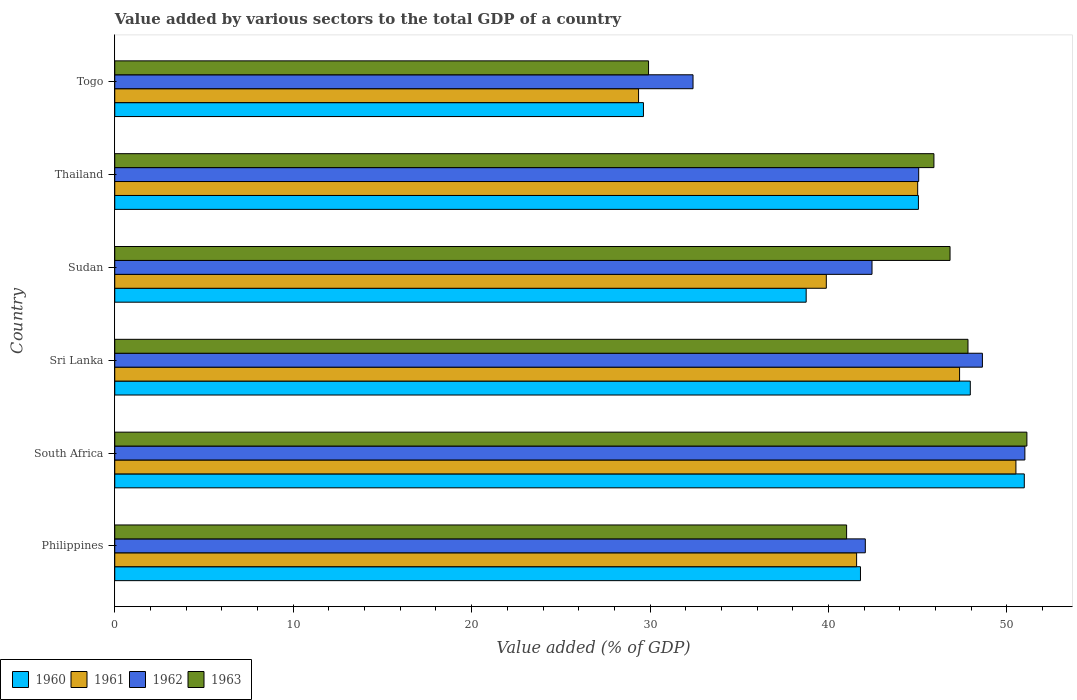How many different coloured bars are there?
Offer a very short reply. 4. Are the number of bars per tick equal to the number of legend labels?
Provide a short and direct response. Yes. How many bars are there on the 4th tick from the top?
Make the answer very short. 4. What is the label of the 5th group of bars from the top?
Make the answer very short. South Africa. In how many cases, is the number of bars for a given country not equal to the number of legend labels?
Offer a terse response. 0. What is the value added by various sectors to the total GDP in 1963 in Sudan?
Ensure brevity in your answer.  46.81. Across all countries, what is the maximum value added by various sectors to the total GDP in 1963?
Provide a short and direct response. 51.12. Across all countries, what is the minimum value added by various sectors to the total GDP in 1962?
Offer a very short reply. 32.41. In which country was the value added by various sectors to the total GDP in 1961 maximum?
Offer a very short reply. South Africa. In which country was the value added by various sectors to the total GDP in 1960 minimum?
Provide a short and direct response. Togo. What is the total value added by various sectors to the total GDP in 1963 in the graph?
Keep it short and to the point. 262.58. What is the difference between the value added by various sectors to the total GDP in 1960 in Philippines and that in Sri Lanka?
Keep it short and to the point. -6.15. What is the difference between the value added by various sectors to the total GDP in 1960 in Thailand and the value added by various sectors to the total GDP in 1962 in Sri Lanka?
Offer a terse response. -3.59. What is the average value added by various sectors to the total GDP in 1962 per country?
Make the answer very short. 43.6. What is the difference between the value added by various sectors to the total GDP in 1962 and value added by various sectors to the total GDP in 1961 in South Africa?
Make the answer very short. 0.5. What is the ratio of the value added by various sectors to the total GDP in 1962 in Philippines to that in Sri Lanka?
Offer a terse response. 0.87. Is the value added by various sectors to the total GDP in 1960 in Thailand less than that in Togo?
Give a very brief answer. No. Is the difference between the value added by various sectors to the total GDP in 1962 in South Africa and Sudan greater than the difference between the value added by various sectors to the total GDP in 1961 in South Africa and Sudan?
Make the answer very short. No. What is the difference between the highest and the second highest value added by various sectors to the total GDP in 1963?
Your answer should be compact. 3.3. What is the difference between the highest and the lowest value added by various sectors to the total GDP in 1963?
Provide a short and direct response. 21.2. In how many countries, is the value added by various sectors to the total GDP in 1963 greater than the average value added by various sectors to the total GDP in 1963 taken over all countries?
Your answer should be very brief. 4. Is the sum of the value added by various sectors to the total GDP in 1962 in Sudan and Togo greater than the maximum value added by various sectors to the total GDP in 1960 across all countries?
Your response must be concise. Yes. Is it the case that in every country, the sum of the value added by various sectors to the total GDP in 1962 and value added by various sectors to the total GDP in 1963 is greater than the sum of value added by various sectors to the total GDP in 1960 and value added by various sectors to the total GDP in 1961?
Give a very brief answer. No. Is it the case that in every country, the sum of the value added by various sectors to the total GDP in 1963 and value added by various sectors to the total GDP in 1960 is greater than the value added by various sectors to the total GDP in 1962?
Offer a very short reply. Yes. How many bars are there?
Provide a short and direct response. 24. What is the difference between two consecutive major ticks on the X-axis?
Your answer should be very brief. 10. Does the graph contain grids?
Provide a short and direct response. No. How many legend labels are there?
Provide a short and direct response. 4. What is the title of the graph?
Ensure brevity in your answer.  Value added by various sectors to the total GDP of a country. Does "1982" appear as one of the legend labels in the graph?
Your answer should be very brief. No. What is the label or title of the X-axis?
Offer a terse response. Value added (% of GDP). What is the label or title of the Y-axis?
Keep it short and to the point. Country. What is the Value added (% of GDP) in 1960 in Philippines?
Keep it short and to the point. 41.79. What is the Value added (% of GDP) in 1961 in Philippines?
Offer a terse response. 41.57. What is the Value added (% of GDP) of 1962 in Philippines?
Ensure brevity in your answer.  42.06. What is the Value added (% of GDP) in 1963 in Philippines?
Keep it short and to the point. 41.01. What is the Value added (% of GDP) of 1960 in South Africa?
Offer a terse response. 50.97. What is the Value added (% of GDP) in 1961 in South Africa?
Your response must be concise. 50.5. What is the Value added (% of GDP) in 1962 in South Africa?
Keep it short and to the point. 51.01. What is the Value added (% of GDP) of 1963 in South Africa?
Offer a very short reply. 51.12. What is the Value added (% of GDP) of 1960 in Sri Lanka?
Keep it short and to the point. 47.95. What is the Value added (% of GDP) in 1961 in Sri Lanka?
Give a very brief answer. 47.35. What is the Value added (% of GDP) of 1962 in Sri Lanka?
Keep it short and to the point. 48.62. What is the Value added (% of GDP) of 1963 in Sri Lanka?
Provide a succinct answer. 47.82. What is the Value added (% of GDP) of 1960 in Sudan?
Offer a very short reply. 38.75. What is the Value added (% of GDP) in 1961 in Sudan?
Ensure brevity in your answer.  39.88. What is the Value added (% of GDP) of 1962 in Sudan?
Ensure brevity in your answer.  42.44. What is the Value added (% of GDP) in 1963 in Sudan?
Offer a very short reply. 46.81. What is the Value added (% of GDP) in 1960 in Thailand?
Keep it short and to the point. 45.04. What is the Value added (% of GDP) in 1961 in Thailand?
Your response must be concise. 45. What is the Value added (% of GDP) of 1962 in Thailand?
Offer a very short reply. 45.05. What is the Value added (% of GDP) in 1963 in Thailand?
Make the answer very short. 45.91. What is the Value added (% of GDP) of 1960 in Togo?
Ensure brevity in your answer.  29.63. What is the Value added (% of GDP) in 1961 in Togo?
Your answer should be compact. 29.35. What is the Value added (% of GDP) in 1962 in Togo?
Provide a succinct answer. 32.41. What is the Value added (% of GDP) of 1963 in Togo?
Your answer should be compact. 29.91. Across all countries, what is the maximum Value added (% of GDP) of 1960?
Give a very brief answer. 50.97. Across all countries, what is the maximum Value added (% of GDP) of 1961?
Offer a terse response. 50.5. Across all countries, what is the maximum Value added (% of GDP) in 1962?
Provide a short and direct response. 51.01. Across all countries, what is the maximum Value added (% of GDP) in 1963?
Give a very brief answer. 51.12. Across all countries, what is the minimum Value added (% of GDP) of 1960?
Your answer should be compact. 29.63. Across all countries, what is the minimum Value added (% of GDP) in 1961?
Your response must be concise. 29.35. Across all countries, what is the minimum Value added (% of GDP) in 1962?
Offer a terse response. 32.41. Across all countries, what is the minimum Value added (% of GDP) in 1963?
Offer a very short reply. 29.91. What is the total Value added (% of GDP) in 1960 in the graph?
Keep it short and to the point. 254.13. What is the total Value added (% of GDP) of 1961 in the graph?
Ensure brevity in your answer.  253.65. What is the total Value added (% of GDP) of 1962 in the graph?
Give a very brief answer. 261.59. What is the total Value added (% of GDP) of 1963 in the graph?
Your response must be concise. 262.58. What is the difference between the Value added (% of GDP) in 1960 in Philippines and that in South Africa?
Your answer should be very brief. -9.18. What is the difference between the Value added (% of GDP) in 1961 in Philippines and that in South Africa?
Your response must be concise. -8.93. What is the difference between the Value added (% of GDP) in 1962 in Philippines and that in South Africa?
Give a very brief answer. -8.94. What is the difference between the Value added (% of GDP) of 1963 in Philippines and that in South Africa?
Give a very brief answer. -10.1. What is the difference between the Value added (% of GDP) in 1960 in Philippines and that in Sri Lanka?
Provide a short and direct response. -6.15. What is the difference between the Value added (% of GDP) in 1961 in Philippines and that in Sri Lanka?
Provide a succinct answer. -5.77. What is the difference between the Value added (% of GDP) of 1962 in Philippines and that in Sri Lanka?
Give a very brief answer. -6.56. What is the difference between the Value added (% of GDP) of 1963 in Philippines and that in Sri Lanka?
Offer a terse response. -6.8. What is the difference between the Value added (% of GDP) in 1960 in Philippines and that in Sudan?
Keep it short and to the point. 3.04. What is the difference between the Value added (% of GDP) of 1961 in Philippines and that in Sudan?
Your answer should be compact. 1.7. What is the difference between the Value added (% of GDP) of 1962 in Philippines and that in Sudan?
Give a very brief answer. -0.38. What is the difference between the Value added (% of GDP) in 1963 in Philippines and that in Sudan?
Your response must be concise. -5.8. What is the difference between the Value added (% of GDP) of 1960 in Philippines and that in Thailand?
Give a very brief answer. -3.25. What is the difference between the Value added (% of GDP) in 1961 in Philippines and that in Thailand?
Keep it short and to the point. -3.42. What is the difference between the Value added (% of GDP) of 1962 in Philippines and that in Thailand?
Ensure brevity in your answer.  -2.99. What is the difference between the Value added (% of GDP) in 1963 in Philippines and that in Thailand?
Your response must be concise. -4.89. What is the difference between the Value added (% of GDP) in 1960 in Philippines and that in Togo?
Offer a terse response. 12.16. What is the difference between the Value added (% of GDP) in 1961 in Philippines and that in Togo?
Give a very brief answer. 12.22. What is the difference between the Value added (% of GDP) of 1962 in Philippines and that in Togo?
Provide a short and direct response. 9.66. What is the difference between the Value added (% of GDP) of 1963 in Philippines and that in Togo?
Make the answer very short. 11.1. What is the difference between the Value added (% of GDP) of 1960 in South Africa and that in Sri Lanka?
Provide a succinct answer. 3.03. What is the difference between the Value added (% of GDP) in 1961 in South Africa and that in Sri Lanka?
Your answer should be very brief. 3.16. What is the difference between the Value added (% of GDP) of 1962 in South Africa and that in Sri Lanka?
Offer a terse response. 2.38. What is the difference between the Value added (% of GDP) in 1963 in South Africa and that in Sri Lanka?
Offer a terse response. 3.3. What is the difference between the Value added (% of GDP) of 1960 in South Africa and that in Sudan?
Make the answer very short. 12.22. What is the difference between the Value added (% of GDP) in 1961 in South Africa and that in Sudan?
Provide a short and direct response. 10.63. What is the difference between the Value added (% of GDP) of 1962 in South Africa and that in Sudan?
Your response must be concise. 8.57. What is the difference between the Value added (% of GDP) in 1963 in South Africa and that in Sudan?
Offer a very short reply. 4.31. What is the difference between the Value added (% of GDP) in 1960 in South Africa and that in Thailand?
Provide a succinct answer. 5.93. What is the difference between the Value added (% of GDP) in 1961 in South Africa and that in Thailand?
Provide a succinct answer. 5.51. What is the difference between the Value added (% of GDP) of 1962 in South Africa and that in Thailand?
Keep it short and to the point. 5.95. What is the difference between the Value added (% of GDP) in 1963 in South Africa and that in Thailand?
Offer a terse response. 5.21. What is the difference between the Value added (% of GDP) of 1960 in South Africa and that in Togo?
Make the answer very short. 21.34. What is the difference between the Value added (% of GDP) of 1961 in South Africa and that in Togo?
Give a very brief answer. 21.15. What is the difference between the Value added (% of GDP) of 1962 in South Africa and that in Togo?
Your answer should be very brief. 18.6. What is the difference between the Value added (% of GDP) of 1963 in South Africa and that in Togo?
Offer a very short reply. 21.2. What is the difference between the Value added (% of GDP) of 1960 in Sri Lanka and that in Sudan?
Make the answer very short. 9.2. What is the difference between the Value added (% of GDP) in 1961 in Sri Lanka and that in Sudan?
Provide a succinct answer. 7.47. What is the difference between the Value added (% of GDP) in 1962 in Sri Lanka and that in Sudan?
Ensure brevity in your answer.  6.19. What is the difference between the Value added (% of GDP) in 1960 in Sri Lanka and that in Thailand?
Give a very brief answer. 2.91. What is the difference between the Value added (% of GDP) in 1961 in Sri Lanka and that in Thailand?
Give a very brief answer. 2.35. What is the difference between the Value added (% of GDP) of 1962 in Sri Lanka and that in Thailand?
Your answer should be compact. 3.57. What is the difference between the Value added (% of GDP) of 1963 in Sri Lanka and that in Thailand?
Your answer should be very brief. 1.91. What is the difference between the Value added (% of GDP) of 1960 in Sri Lanka and that in Togo?
Keep it short and to the point. 18.32. What is the difference between the Value added (% of GDP) in 1961 in Sri Lanka and that in Togo?
Offer a very short reply. 17.99. What is the difference between the Value added (% of GDP) of 1962 in Sri Lanka and that in Togo?
Your response must be concise. 16.22. What is the difference between the Value added (% of GDP) of 1963 in Sri Lanka and that in Togo?
Make the answer very short. 17.9. What is the difference between the Value added (% of GDP) of 1960 in Sudan and that in Thailand?
Your response must be concise. -6.29. What is the difference between the Value added (% of GDP) in 1961 in Sudan and that in Thailand?
Your answer should be compact. -5.12. What is the difference between the Value added (% of GDP) in 1962 in Sudan and that in Thailand?
Your answer should be very brief. -2.62. What is the difference between the Value added (% of GDP) in 1963 in Sudan and that in Thailand?
Your answer should be compact. 0.9. What is the difference between the Value added (% of GDP) of 1960 in Sudan and that in Togo?
Ensure brevity in your answer.  9.12. What is the difference between the Value added (% of GDP) in 1961 in Sudan and that in Togo?
Your answer should be compact. 10.52. What is the difference between the Value added (% of GDP) in 1962 in Sudan and that in Togo?
Offer a very short reply. 10.03. What is the difference between the Value added (% of GDP) of 1963 in Sudan and that in Togo?
Ensure brevity in your answer.  16.9. What is the difference between the Value added (% of GDP) of 1960 in Thailand and that in Togo?
Provide a succinct answer. 15.41. What is the difference between the Value added (% of GDP) of 1961 in Thailand and that in Togo?
Offer a very short reply. 15.64. What is the difference between the Value added (% of GDP) of 1962 in Thailand and that in Togo?
Keep it short and to the point. 12.65. What is the difference between the Value added (% of GDP) in 1963 in Thailand and that in Togo?
Your answer should be compact. 15.99. What is the difference between the Value added (% of GDP) of 1960 in Philippines and the Value added (% of GDP) of 1961 in South Africa?
Offer a very short reply. -8.71. What is the difference between the Value added (% of GDP) in 1960 in Philippines and the Value added (% of GDP) in 1962 in South Africa?
Your response must be concise. -9.21. What is the difference between the Value added (% of GDP) in 1960 in Philippines and the Value added (% of GDP) in 1963 in South Africa?
Give a very brief answer. -9.33. What is the difference between the Value added (% of GDP) in 1961 in Philippines and the Value added (% of GDP) in 1962 in South Africa?
Provide a succinct answer. -9.43. What is the difference between the Value added (% of GDP) of 1961 in Philippines and the Value added (% of GDP) of 1963 in South Africa?
Make the answer very short. -9.54. What is the difference between the Value added (% of GDP) of 1962 in Philippines and the Value added (% of GDP) of 1963 in South Africa?
Give a very brief answer. -9.05. What is the difference between the Value added (% of GDP) in 1960 in Philippines and the Value added (% of GDP) in 1961 in Sri Lanka?
Your answer should be compact. -5.55. What is the difference between the Value added (% of GDP) of 1960 in Philippines and the Value added (% of GDP) of 1962 in Sri Lanka?
Give a very brief answer. -6.83. What is the difference between the Value added (% of GDP) in 1960 in Philippines and the Value added (% of GDP) in 1963 in Sri Lanka?
Your answer should be very brief. -6.03. What is the difference between the Value added (% of GDP) of 1961 in Philippines and the Value added (% of GDP) of 1962 in Sri Lanka?
Keep it short and to the point. -7.05. What is the difference between the Value added (% of GDP) in 1961 in Philippines and the Value added (% of GDP) in 1963 in Sri Lanka?
Provide a short and direct response. -6.24. What is the difference between the Value added (% of GDP) of 1962 in Philippines and the Value added (% of GDP) of 1963 in Sri Lanka?
Give a very brief answer. -5.75. What is the difference between the Value added (% of GDP) in 1960 in Philippines and the Value added (% of GDP) in 1961 in Sudan?
Offer a very short reply. 1.91. What is the difference between the Value added (% of GDP) of 1960 in Philippines and the Value added (% of GDP) of 1962 in Sudan?
Provide a succinct answer. -0.65. What is the difference between the Value added (% of GDP) of 1960 in Philippines and the Value added (% of GDP) of 1963 in Sudan?
Give a very brief answer. -5.02. What is the difference between the Value added (% of GDP) of 1961 in Philippines and the Value added (% of GDP) of 1962 in Sudan?
Your response must be concise. -0.86. What is the difference between the Value added (% of GDP) of 1961 in Philippines and the Value added (% of GDP) of 1963 in Sudan?
Provide a succinct answer. -5.24. What is the difference between the Value added (% of GDP) of 1962 in Philippines and the Value added (% of GDP) of 1963 in Sudan?
Keep it short and to the point. -4.75. What is the difference between the Value added (% of GDP) of 1960 in Philippines and the Value added (% of GDP) of 1961 in Thailand?
Provide a short and direct response. -3.21. What is the difference between the Value added (% of GDP) of 1960 in Philippines and the Value added (% of GDP) of 1962 in Thailand?
Offer a terse response. -3.26. What is the difference between the Value added (% of GDP) of 1960 in Philippines and the Value added (% of GDP) of 1963 in Thailand?
Keep it short and to the point. -4.12. What is the difference between the Value added (% of GDP) in 1961 in Philippines and the Value added (% of GDP) in 1962 in Thailand?
Your response must be concise. -3.48. What is the difference between the Value added (% of GDP) of 1961 in Philippines and the Value added (% of GDP) of 1963 in Thailand?
Your response must be concise. -4.33. What is the difference between the Value added (% of GDP) of 1962 in Philippines and the Value added (% of GDP) of 1963 in Thailand?
Provide a short and direct response. -3.84. What is the difference between the Value added (% of GDP) in 1960 in Philippines and the Value added (% of GDP) in 1961 in Togo?
Offer a very short reply. 12.44. What is the difference between the Value added (% of GDP) of 1960 in Philippines and the Value added (% of GDP) of 1962 in Togo?
Your answer should be very brief. 9.38. What is the difference between the Value added (% of GDP) in 1960 in Philippines and the Value added (% of GDP) in 1963 in Togo?
Your answer should be compact. 11.88. What is the difference between the Value added (% of GDP) in 1961 in Philippines and the Value added (% of GDP) in 1962 in Togo?
Your answer should be compact. 9.17. What is the difference between the Value added (% of GDP) of 1961 in Philippines and the Value added (% of GDP) of 1963 in Togo?
Your answer should be compact. 11.66. What is the difference between the Value added (% of GDP) of 1962 in Philippines and the Value added (% of GDP) of 1963 in Togo?
Offer a terse response. 12.15. What is the difference between the Value added (% of GDP) of 1960 in South Africa and the Value added (% of GDP) of 1961 in Sri Lanka?
Give a very brief answer. 3.63. What is the difference between the Value added (% of GDP) in 1960 in South Africa and the Value added (% of GDP) in 1962 in Sri Lanka?
Your answer should be compact. 2.35. What is the difference between the Value added (% of GDP) in 1960 in South Africa and the Value added (% of GDP) in 1963 in Sri Lanka?
Offer a very short reply. 3.16. What is the difference between the Value added (% of GDP) of 1961 in South Africa and the Value added (% of GDP) of 1962 in Sri Lanka?
Make the answer very short. 1.88. What is the difference between the Value added (% of GDP) of 1961 in South Africa and the Value added (% of GDP) of 1963 in Sri Lanka?
Offer a very short reply. 2.69. What is the difference between the Value added (% of GDP) of 1962 in South Africa and the Value added (% of GDP) of 1963 in Sri Lanka?
Offer a terse response. 3.19. What is the difference between the Value added (% of GDP) in 1960 in South Africa and the Value added (% of GDP) in 1961 in Sudan?
Your answer should be compact. 11.09. What is the difference between the Value added (% of GDP) in 1960 in South Africa and the Value added (% of GDP) in 1962 in Sudan?
Offer a very short reply. 8.53. What is the difference between the Value added (% of GDP) of 1960 in South Africa and the Value added (% of GDP) of 1963 in Sudan?
Provide a short and direct response. 4.16. What is the difference between the Value added (% of GDP) in 1961 in South Africa and the Value added (% of GDP) in 1962 in Sudan?
Give a very brief answer. 8.07. What is the difference between the Value added (% of GDP) of 1961 in South Africa and the Value added (% of GDP) of 1963 in Sudan?
Your answer should be compact. 3.69. What is the difference between the Value added (% of GDP) in 1962 in South Africa and the Value added (% of GDP) in 1963 in Sudan?
Give a very brief answer. 4.19. What is the difference between the Value added (% of GDP) in 1960 in South Africa and the Value added (% of GDP) in 1961 in Thailand?
Ensure brevity in your answer.  5.98. What is the difference between the Value added (% of GDP) of 1960 in South Africa and the Value added (% of GDP) of 1962 in Thailand?
Your answer should be compact. 5.92. What is the difference between the Value added (% of GDP) of 1960 in South Africa and the Value added (% of GDP) of 1963 in Thailand?
Provide a short and direct response. 5.06. What is the difference between the Value added (% of GDP) in 1961 in South Africa and the Value added (% of GDP) in 1962 in Thailand?
Your answer should be compact. 5.45. What is the difference between the Value added (% of GDP) in 1961 in South Africa and the Value added (% of GDP) in 1963 in Thailand?
Ensure brevity in your answer.  4.6. What is the difference between the Value added (% of GDP) of 1962 in South Africa and the Value added (% of GDP) of 1963 in Thailand?
Your answer should be compact. 5.1. What is the difference between the Value added (% of GDP) in 1960 in South Africa and the Value added (% of GDP) in 1961 in Togo?
Provide a succinct answer. 21.62. What is the difference between the Value added (% of GDP) of 1960 in South Africa and the Value added (% of GDP) of 1962 in Togo?
Offer a terse response. 18.56. What is the difference between the Value added (% of GDP) of 1960 in South Africa and the Value added (% of GDP) of 1963 in Togo?
Offer a very short reply. 21.06. What is the difference between the Value added (% of GDP) of 1961 in South Africa and the Value added (% of GDP) of 1962 in Togo?
Give a very brief answer. 18.1. What is the difference between the Value added (% of GDP) in 1961 in South Africa and the Value added (% of GDP) in 1963 in Togo?
Make the answer very short. 20.59. What is the difference between the Value added (% of GDP) of 1962 in South Africa and the Value added (% of GDP) of 1963 in Togo?
Make the answer very short. 21.09. What is the difference between the Value added (% of GDP) in 1960 in Sri Lanka and the Value added (% of GDP) in 1961 in Sudan?
Offer a very short reply. 8.07. What is the difference between the Value added (% of GDP) in 1960 in Sri Lanka and the Value added (% of GDP) in 1962 in Sudan?
Provide a succinct answer. 5.51. What is the difference between the Value added (% of GDP) of 1960 in Sri Lanka and the Value added (% of GDP) of 1963 in Sudan?
Keep it short and to the point. 1.14. What is the difference between the Value added (% of GDP) in 1961 in Sri Lanka and the Value added (% of GDP) in 1962 in Sudan?
Your response must be concise. 4.91. What is the difference between the Value added (% of GDP) in 1961 in Sri Lanka and the Value added (% of GDP) in 1963 in Sudan?
Provide a short and direct response. 0.53. What is the difference between the Value added (% of GDP) of 1962 in Sri Lanka and the Value added (% of GDP) of 1963 in Sudan?
Offer a very short reply. 1.81. What is the difference between the Value added (% of GDP) in 1960 in Sri Lanka and the Value added (% of GDP) in 1961 in Thailand?
Your answer should be compact. 2.95. What is the difference between the Value added (% of GDP) of 1960 in Sri Lanka and the Value added (% of GDP) of 1962 in Thailand?
Provide a succinct answer. 2.89. What is the difference between the Value added (% of GDP) in 1960 in Sri Lanka and the Value added (% of GDP) in 1963 in Thailand?
Your response must be concise. 2.04. What is the difference between the Value added (% of GDP) of 1961 in Sri Lanka and the Value added (% of GDP) of 1962 in Thailand?
Keep it short and to the point. 2.29. What is the difference between the Value added (% of GDP) of 1961 in Sri Lanka and the Value added (% of GDP) of 1963 in Thailand?
Provide a succinct answer. 1.44. What is the difference between the Value added (% of GDP) in 1962 in Sri Lanka and the Value added (% of GDP) in 1963 in Thailand?
Offer a terse response. 2.72. What is the difference between the Value added (% of GDP) in 1960 in Sri Lanka and the Value added (% of GDP) in 1961 in Togo?
Give a very brief answer. 18.59. What is the difference between the Value added (% of GDP) in 1960 in Sri Lanka and the Value added (% of GDP) in 1962 in Togo?
Ensure brevity in your answer.  15.54. What is the difference between the Value added (% of GDP) of 1960 in Sri Lanka and the Value added (% of GDP) of 1963 in Togo?
Provide a succinct answer. 18.03. What is the difference between the Value added (% of GDP) of 1961 in Sri Lanka and the Value added (% of GDP) of 1962 in Togo?
Offer a very short reply. 14.94. What is the difference between the Value added (% of GDP) of 1961 in Sri Lanka and the Value added (% of GDP) of 1963 in Togo?
Your answer should be very brief. 17.43. What is the difference between the Value added (% of GDP) of 1962 in Sri Lanka and the Value added (% of GDP) of 1963 in Togo?
Make the answer very short. 18.71. What is the difference between the Value added (% of GDP) of 1960 in Sudan and the Value added (% of GDP) of 1961 in Thailand?
Your response must be concise. -6.25. What is the difference between the Value added (% of GDP) in 1960 in Sudan and the Value added (% of GDP) in 1962 in Thailand?
Provide a short and direct response. -6.31. What is the difference between the Value added (% of GDP) of 1960 in Sudan and the Value added (% of GDP) of 1963 in Thailand?
Offer a terse response. -7.16. What is the difference between the Value added (% of GDP) in 1961 in Sudan and the Value added (% of GDP) in 1962 in Thailand?
Provide a short and direct response. -5.18. What is the difference between the Value added (% of GDP) of 1961 in Sudan and the Value added (% of GDP) of 1963 in Thailand?
Provide a short and direct response. -6.03. What is the difference between the Value added (% of GDP) of 1962 in Sudan and the Value added (% of GDP) of 1963 in Thailand?
Provide a succinct answer. -3.47. What is the difference between the Value added (% of GDP) in 1960 in Sudan and the Value added (% of GDP) in 1961 in Togo?
Provide a short and direct response. 9.39. What is the difference between the Value added (% of GDP) in 1960 in Sudan and the Value added (% of GDP) in 1962 in Togo?
Give a very brief answer. 6.34. What is the difference between the Value added (% of GDP) in 1960 in Sudan and the Value added (% of GDP) in 1963 in Togo?
Keep it short and to the point. 8.83. What is the difference between the Value added (% of GDP) of 1961 in Sudan and the Value added (% of GDP) of 1962 in Togo?
Offer a very short reply. 7.47. What is the difference between the Value added (% of GDP) of 1961 in Sudan and the Value added (% of GDP) of 1963 in Togo?
Make the answer very short. 9.96. What is the difference between the Value added (% of GDP) of 1962 in Sudan and the Value added (% of GDP) of 1963 in Togo?
Make the answer very short. 12.52. What is the difference between the Value added (% of GDP) of 1960 in Thailand and the Value added (% of GDP) of 1961 in Togo?
Offer a terse response. 15.68. What is the difference between the Value added (% of GDP) in 1960 in Thailand and the Value added (% of GDP) in 1962 in Togo?
Offer a very short reply. 12.63. What is the difference between the Value added (% of GDP) in 1960 in Thailand and the Value added (% of GDP) in 1963 in Togo?
Provide a succinct answer. 15.12. What is the difference between the Value added (% of GDP) of 1961 in Thailand and the Value added (% of GDP) of 1962 in Togo?
Your answer should be compact. 12.59. What is the difference between the Value added (% of GDP) in 1961 in Thailand and the Value added (% of GDP) in 1963 in Togo?
Your answer should be very brief. 15.08. What is the difference between the Value added (% of GDP) of 1962 in Thailand and the Value added (% of GDP) of 1963 in Togo?
Provide a succinct answer. 15.14. What is the average Value added (% of GDP) in 1960 per country?
Give a very brief answer. 42.35. What is the average Value added (% of GDP) in 1961 per country?
Offer a terse response. 42.28. What is the average Value added (% of GDP) of 1962 per country?
Offer a very short reply. 43.6. What is the average Value added (% of GDP) of 1963 per country?
Offer a very short reply. 43.76. What is the difference between the Value added (% of GDP) of 1960 and Value added (% of GDP) of 1961 in Philippines?
Provide a short and direct response. 0.22. What is the difference between the Value added (% of GDP) of 1960 and Value added (% of GDP) of 1962 in Philippines?
Offer a very short reply. -0.27. What is the difference between the Value added (% of GDP) in 1960 and Value added (% of GDP) in 1963 in Philippines?
Offer a terse response. 0.78. What is the difference between the Value added (% of GDP) of 1961 and Value added (% of GDP) of 1962 in Philippines?
Your response must be concise. -0.49. What is the difference between the Value added (% of GDP) in 1961 and Value added (% of GDP) in 1963 in Philippines?
Make the answer very short. 0.56. What is the difference between the Value added (% of GDP) in 1962 and Value added (% of GDP) in 1963 in Philippines?
Ensure brevity in your answer.  1.05. What is the difference between the Value added (% of GDP) of 1960 and Value added (% of GDP) of 1961 in South Africa?
Ensure brevity in your answer.  0.47. What is the difference between the Value added (% of GDP) of 1960 and Value added (% of GDP) of 1962 in South Africa?
Your answer should be compact. -0.03. What is the difference between the Value added (% of GDP) of 1960 and Value added (% of GDP) of 1963 in South Africa?
Ensure brevity in your answer.  -0.15. What is the difference between the Value added (% of GDP) of 1961 and Value added (% of GDP) of 1962 in South Africa?
Give a very brief answer. -0.5. What is the difference between the Value added (% of GDP) of 1961 and Value added (% of GDP) of 1963 in South Africa?
Provide a succinct answer. -0.61. What is the difference between the Value added (% of GDP) of 1962 and Value added (% of GDP) of 1963 in South Africa?
Offer a terse response. -0.11. What is the difference between the Value added (% of GDP) in 1960 and Value added (% of GDP) in 1961 in Sri Lanka?
Offer a terse response. 0.6. What is the difference between the Value added (% of GDP) of 1960 and Value added (% of GDP) of 1962 in Sri Lanka?
Provide a succinct answer. -0.68. What is the difference between the Value added (% of GDP) in 1960 and Value added (% of GDP) in 1963 in Sri Lanka?
Offer a very short reply. 0.13. What is the difference between the Value added (% of GDP) of 1961 and Value added (% of GDP) of 1962 in Sri Lanka?
Give a very brief answer. -1.28. What is the difference between the Value added (% of GDP) of 1961 and Value added (% of GDP) of 1963 in Sri Lanka?
Offer a very short reply. -0.47. What is the difference between the Value added (% of GDP) of 1962 and Value added (% of GDP) of 1963 in Sri Lanka?
Provide a short and direct response. 0.81. What is the difference between the Value added (% of GDP) of 1960 and Value added (% of GDP) of 1961 in Sudan?
Keep it short and to the point. -1.13. What is the difference between the Value added (% of GDP) of 1960 and Value added (% of GDP) of 1962 in Sudan?
Your response must be concise. -3.69. What is the difference between the Value added (% of GDP) in 1960 and Value added (% of GDP) in 1963 in Sudan?
Offer a terse response. -8.06. What is the difference between the Value added (% of GDP) of 1961 and Value added (% of GDP) of 1962 in Sudan?
Your answer should be very brief. -2.56. What is the difference between the Value added (% of GDP) in 1961 and Value added (% of GDP) in 1963 in Sudan?
Give a very brief answer. -6.93. What is the difference between the Value added (% of GDP) in 1962 and Value added (% of GDP) in 1963 in Sudan?
Offer a terse response. -4.37. What is the difference between the Value added (% of GDP) of 1960 and Value added (% of GDP) of 1961 in Thailand?
Ensure brevity in your answer.  0.04. What is the difference between the Value added (% of GDP) in 1960 and Value added (% of GDP) in 1962 in Thailand?
Offer a very short reply. -0.02. What is the difference between the Value added (% of GDP) of 1960 and Value added (% of GDP) of 1963 in Thailand?
Your answer should be very brief. -0.87. What is the difference between the Value added (% of GDP) of 1961 and Value added (% of GDP) of 1962 in Thailand?
Offer a terse response. -0.06. What is the difference between the Value added (% of GDP) in 1961 and Value added (% of GDP) in 1963 in Thailand?
Ensure brevity in your answer.  -0.91. What is the difference between the Value added (% of GDP) of 1962 and Value added (% of GDP) of 1963 in Thailand?
Offer a very short reply. -0.85. What is the difference between the Value added (% of GDP) of 1960 and Value added (% of GDP) of 1961 in Togo?
Give a very brief answer. 0.27. What is the difference between the Value added (% of GDP) of 1960 and Value added (% of GDP) of 1962 in Togo?
Keep it short and to the point. -2.78. What is the difference between the Value added (% of GDP) in 1960 and Value added (% of GDP) in 1963 in Togo?
Make the answer very short. -0.28. What is the difference between the Value added (% of GDP) in 1961 and Value added (% of GDP) in 1962 in Togo?
Offer a very short reply. -3.05. What is the difference between the Value added (% of GDP) of 1961 and Value added (% of GDP) of 1963 in Togo?
Offer a very short reply. -0.56. What is the difference between the Value added (% of GDP) of 1962 and Value added (% of GDP) of 1963 in Togo?
Your answer should be very brief. 2.49. What is the ratio of the Value added (% of GDP) of 1960 in Philippines to that in South Africa?
Provide a short and direct response. 0.82. What is the ratio of the Value added (% of GDP) in 1961 in Philippines to that in South Africa?
Your response must be concise. 0.82. What is the ratio of the Value added (% of GDP) in 1962 in Philippines to that in South Africa?
Keep it short and to the point. 0.82. What is the ratio of the Value added (% of GDP) of 1963 in Philippines to that in South Africa?
Your answer should be very brief. 0.8. What is the ratio of the Value added (% of GDP) in 1960 in Philippines to that in Sri Lanka?
Your answer should be very brief. 0.87. What is the ratio of the Value added (% of GDP) in 1961 in Philippines to that in Sri Lanka?
Keep it short and to the point. 0.88. What is the ratio of the Value added (% of GDP) of 1962 in Philippines to that in Sri Lanka?
Offer a very short reply. 0.87. What is the ratio of the Value added (% of GDP) of 1963 in Philippines to that in Sri Lanka?
Make the answer very short. 0.86. What is the ratio of the Value added (% of GDP) in 1960 in Philippines to that in Sudan?
Give a very brief answer. 1.08. What is the ratio of the Value added (% of GDP) of 1961 in Philippines to that in Sudan?
Ensure brevity in your answer.  1.04. What is the ratio of the Value added (% of GDP) of 1962 in Philippines to that in Sudan?
Your answer should be very brief. 0.99. What is the ratio of the Value added (% of GDP) of 1963 in Philippines to that in Sudan?
Your answer should be compact. 0.88. What is the ratio of the Value added (% of GDP) in 1960 in Philippines to that in Thailand?
Ensure brevity in your answer.  0.93. What is the ratio of the Value added (% of GDP) in 1961 in Philippines to that in Thailand?
Provide a succinct answer. 0.92. What is the ratio of the Value added (% of GDP) in 1962 in Philippines to that in Thailand?
Offer a very short reply. 0.93. What is the ratio of the Value added (% of GDP) in 1963 in Philippines to that in Thailand?
Provide a short and direct response. 0.89. What is the ratio of the Value added (% of GDP) of 1960 in Philippines to that in Togo?
Provide a short and direct response. 1.41. What is the ratio of the Value added (% of GDP) of 1961 in Philippines to that in Togo?
Ensure brevity in your answer.  1.42. What is the ratio of the Value added (% of GDP) of 1962 in Philippines to that in Togo?
Offer a very short reply. 1.3. What is the ratio of the Value added (% of GDP) of 1963 in Philippines to that in Togo?
Give a very brief answer. 1.37. What is the ratio of the Value added (% of GDP) in 1960 in South Africa to that in Sri Lanka?
Provide a succinct answer. 1.06. What is the ratio of the Value added (% of GDP) in 1961 in South Africa to that in Sri Lanka?
Your answer should be compact. 1.07. What is the ratio of the Value added (% of GDP) in 1962 in South Africa to that in Sri Lanka?
Ensure brevity in your answer.  1.05. What is the ratio of the Value added (% of GDP) in 1963 in South Africa to that in Sri Lanka?
Provide a short and direct response. 1.07. What is the ratio of the Value added (% of GDP) of 1960 in South Africa to that in Sudan?
Offer a very short reply. 1.32. What is the ratio of the Value added (% of GDP) of 1961 in South Africa to that in Sudan?
Give a very brief answer. 1.27. What is the ratio of the Value added (% of GDP) in 1962 in South Africa to that in Sudan?
Give a very brief answer. 1.2. What is the ratio of the Value added (% of GDP) of 1963 in South Africa to that in Sudan?
Give a very brief answer. 1.09. What is the ratio of the Value added (% of GDP) of 1960 in South Africa to that in Thailand?
Your answer should be very brief. 1.13. What is the ratio of the Value added (% of GDP) of 1961 in South Africa to that in Thailand?
Ensure brevity in your answer.  1.12. What is the ratio of the Value added (% of GDP) in 1962 in South Africa to that in Thailand?
Provide a short and direct response. 1.13. What is the ratio of the Value added (% of GDP) in 1963 in South Africa to that in Thailand?
Offer a terse response. 1.11. What is the ratio of the Value added (% of GDP) in 1960 in South Africa to that in Togo?
Your response must be concise. 1.72. What is the ratio of the Value added (% of GDP) of 1961 in South Africa to that in Togo?
Offer a very short reply. 1.72. What is the ratio of the Value added (% of GDP) in 1962 in South Africa to that in Togo?
Make the answer very short. 1.57. What is the ratio of the Value added (% of GDP) in 1963 in South Africa to that in Togo?
Keep it short and to the point. 1.71. What is the ratio of the Value added (% of GDP) in 1960 in Sri Lanka to that in Sudan?
Offer a terse response. 1.24. What is the ratio of the Value added (% of GDP) in 1961 in Sri Lanka to that in Sudan?
Provide a succinct answer. 1.19. What is the ratio of the Value added (% of GDP) in 1962 in Sri Lanka to that in Sudan?
Ensure brevity in your answer.  1.15. What is the ratio of the Value added (% of GDP) of 1963 in Sri Lanka to that in Sudan?
Give a very brief answer. 1.02. What is the ratio of the Value added (% of GDP) in 1960 in Sri Lanka to that in Thailand?
Offer a very short reply. 1.06. What is the ratio of the Value added (% of GDP) in 1961 in Sri Lanka to that in Thailand?
Ensure brevity in your answer.  1.05. What is the ratio of the Value added (% of GDP) of 1962 in Sri Lanka to that in Thailand?
Keep it short and to the point. 1.08. What is the ratio of the Value added (% of GDP) of 1963 in Sri Lanka to that in Thailand?
Your answer should be very brief. 1.04. What is the ratio of the Value added (% of GDP) of 1960 in Sri Lanka to that in Togo?
Your answer should be very brief. 1.62. What is the ratio of the Value added (% of GDP) in 1961 in Sri Lanka to that in Togo?
Your answer should be compact. 1.61. What is the ratio of the Value added (% of GDP) in 1962 in Sri Lanka to that in Togo?
Offer a very short reply. 1.5. What is the ratio of the Value added (% of GDP) in 1963 in Sri Lanka to that in Togo?
Give a very brief answer. 1.6. What is the ratio of the Value added (% of GDP) in 1960 in Sudan to that in Thailand?
Make the answer very short. 0.86. What is the ratio of the Value added (% of GDP) of 1961 in Sudan to that in Thailand?
Offer a very short reply. 0.89. What is the ratio of the Value added (% of GDP) of 1962 in Sudan to that in Thailand?
Provide a short and direct response. 0.94. What is the ratio of the Value added (% of GDP) of 1963 in Sudan to that in Thailand?
Keep it short and to the point. 1.02. What is the ratio of the Value added (% of GDP) of 1960 in Sudan to that in Togo?
Your answer should be compact. 1.31. What is the ratio of the Value added (% of GDP) of 1961 in Sudan to that in Togo?
Offer a very short reply. 1.36. What is the ratio of the Value added (% of GDP) of 1962 in Sudan to that in Togo?
Offer a very short reply. 1.31. What is the ratio of the Value added (% of GDP) of 1963 in Sudan to that in Togo?
Make the answer very short. 1.56. What is the ratio of the Value added (% of GDP) in 1960 in Thailand to that in Togo?
Offer a terse response. 1.52. What is the ratio of the Value added (% of GDP) in 1961 in Thailand to that in Togo?
Make the answer very short. 1.53. What is the ratio of the Value added (% of GDP) in 1962 in Thailand to that in Togo?
Make the answer very short. 1.39. What is the ratio of the Value added (% of GDP) in 1963 in Thailand to that in Togo?
Provide a succinct answer. 1.53. What is the difference between the highest and the second highest Value added (% of GDP) of 1960?
Keep it short and to the point. 3.03. What is the difference between the highest and the second highest Value added (% of GDP) of 1961?
Your answer should be very brief. 3.16. What is the difference between the highest and the second highest Value added (% of GDP) in 1962?
Your response must be concise. 2.38. What is the difference between the highest and the second highest Value added (% of GDP) in 1963?
Provide a short and direct response. 3.3. What is the difference between the highest and the lowest Value added (% of GDP) in 1960?
Your answer should be very brief. 21.34. What is the difference between the highest and the lowest Value added (% of GDP) of 1961?
Keep it short and to the point. 21.15. What is the difference between the highest and the lowest Value added (% of GDP) in 1962?
Make the answer very short. 18.6. What is the difference between the highest and the lowest Value added (% of GDP) in 1963?
Your response must be concise. 21.2. 